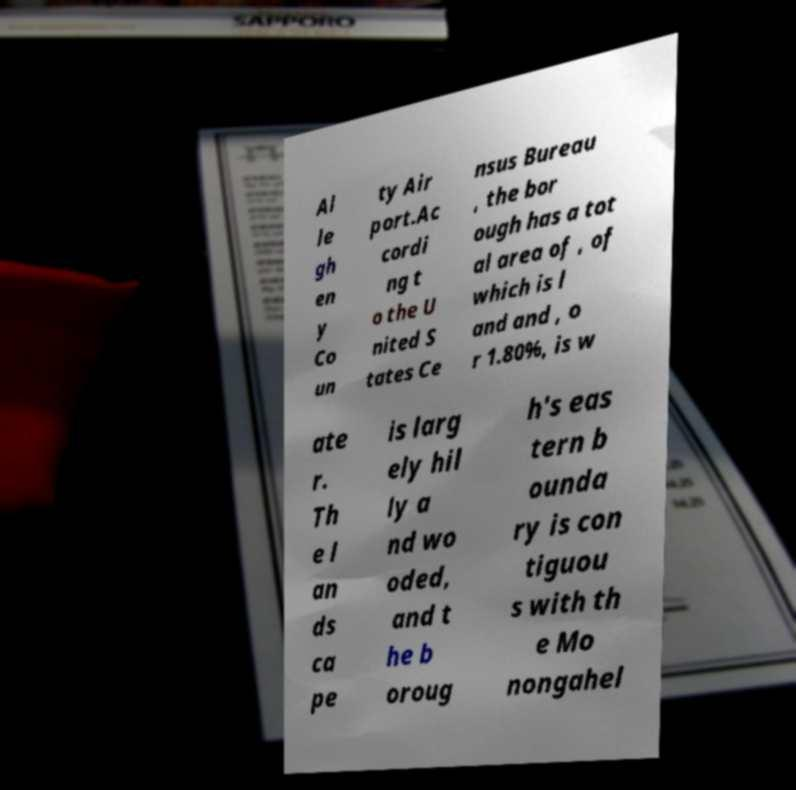Can you read and provide the text displayed in the image?This photo seems to have some interesting text. Can you extract and type it out for me? Al le gh en y Co un ty Air port.Ac cordi ng t o the U nited S tates Ce nsus Bureau , the bor ough has a tot al area of , of which is l and and , o r 1.80%, is w ate r. Th e l an ds ca pe is larg ely hil ly a nd wo oded, and t he b oroug h's eas tern b ounda ry is con tiguou s with th e Mo nongahel 